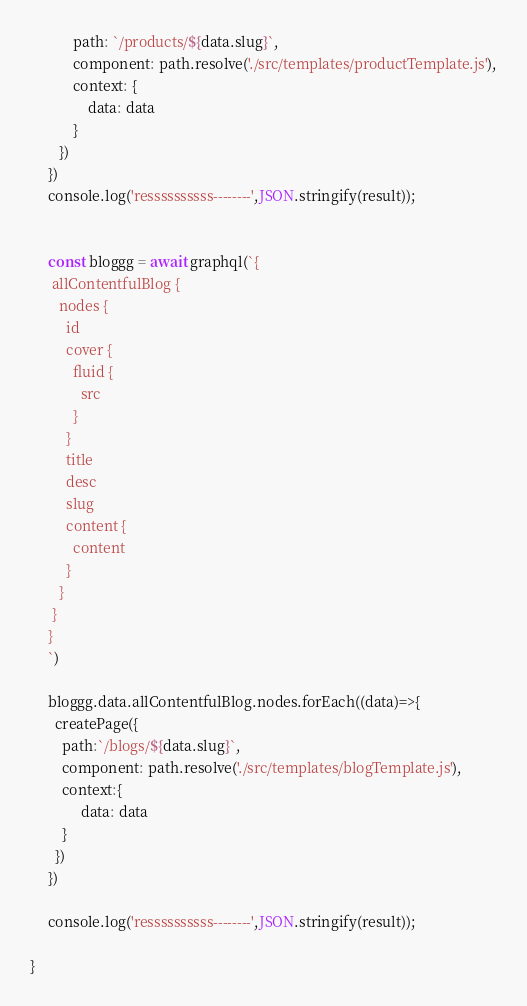Convert code to text. <code><loc_0><loc_0><loc_500><loc_500><_JavaScript_>            path: `/products/${data.slug}`,
            component: path.resolve('./src/templates/productTemplate.js'),
            context: {
                data: data
            }
        })
     })
     console.log('ressssssssss--------',JSON.stringify(result));


     const bloggg = await graphql(`{
      allContentfulBlog {
        nodes {
          id
          cover {
            fluid {
              src
            }
          }
          title
          desc
          slug
          content {
            content
          }
        }
      }
     }
     `)

     bloggg.data.allContentfulBlog.nodes.forEach((data)=>{
       createPage({
         path:`/blogs/${data.slug}`,
         component: path.resolve('./src/templates/blogTemplate.js'),
         context:{
              data: data
         }
       })
     })

     console.log('ressssssssss--------',JSON.stringify(result));

}</code> 